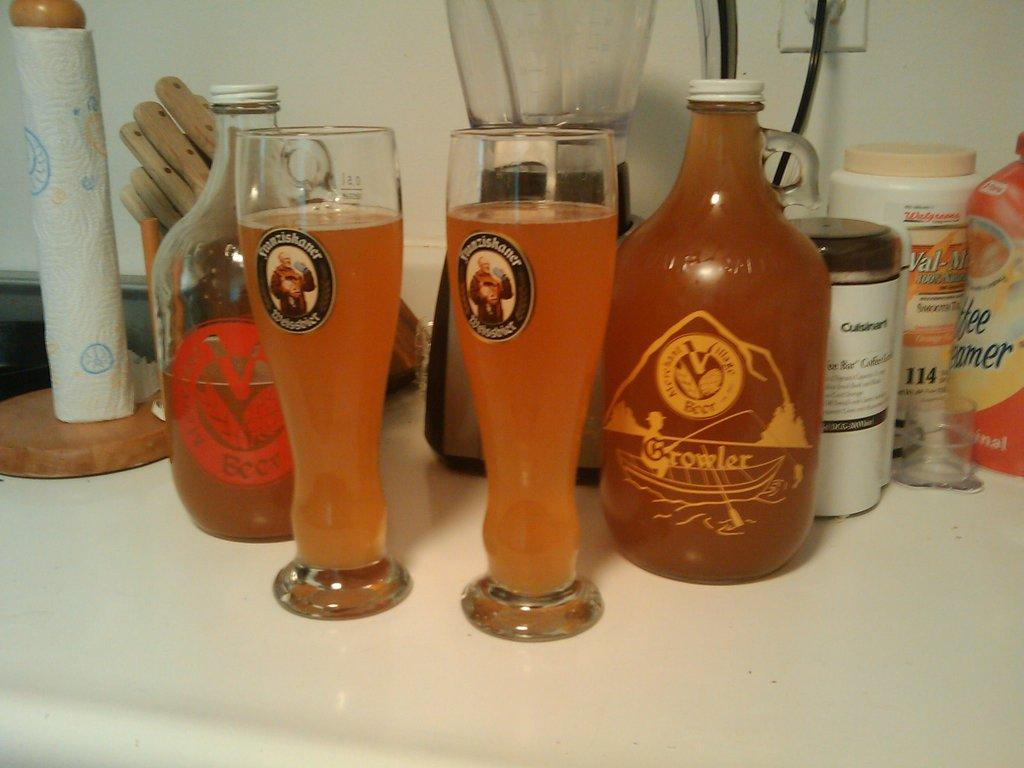<image>
Provide a brief description of the given image. A bottle that has growler written on it 